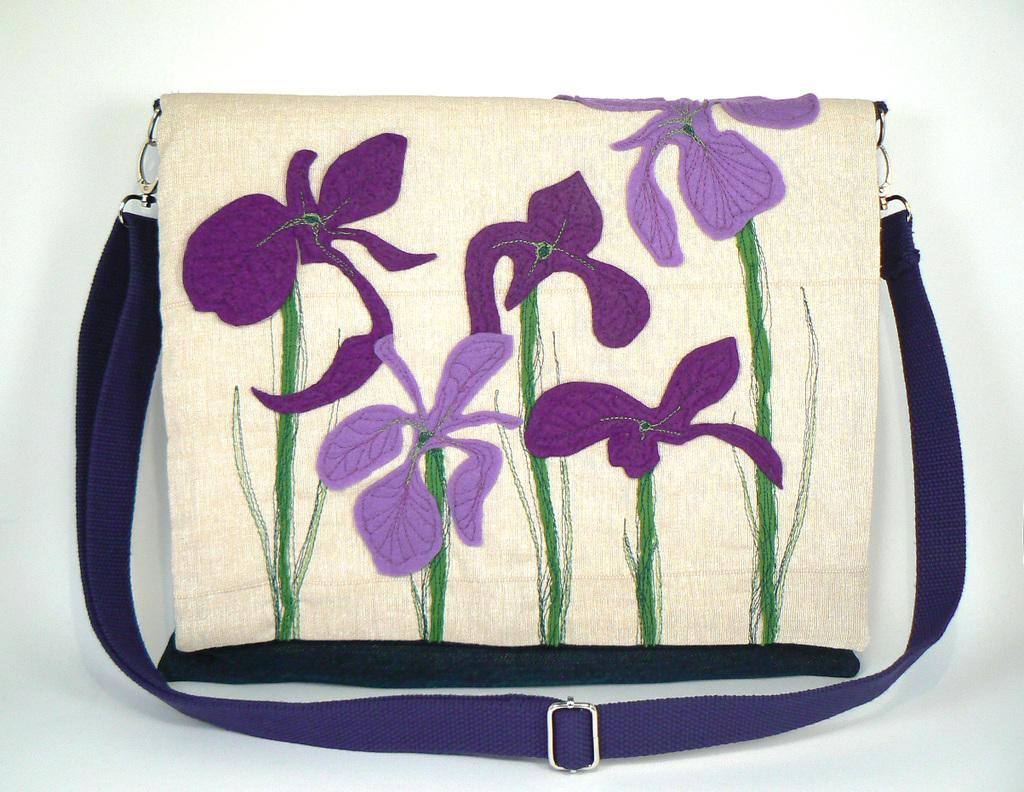What object is present in the image? There is a bag in the image. What design is featured on the bag? There is a thread work of flowers on the bag. Can you see a crown on the bag in the image? There is no crown present on the bag in the image. Is there a beam supporting the bag in the image? There is no beam present in the image, and the bag is not being supported by any visible structure. 